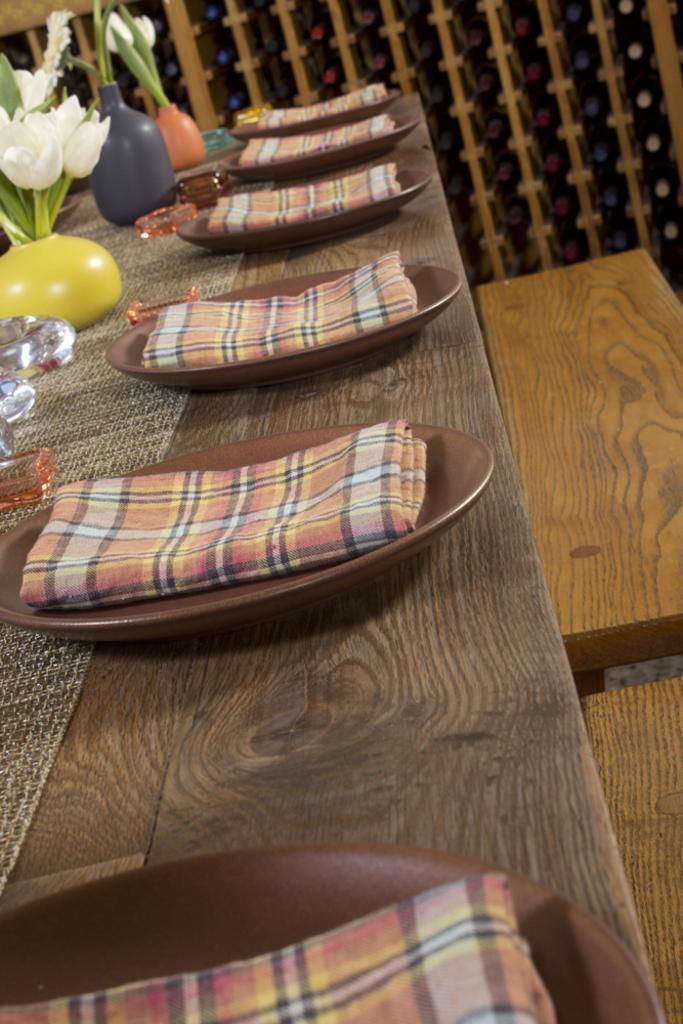Can you describe this image briefly? In this image there is a table having plates, flower vases and few objects. There are napkins on the plates. There are flowers and leaves in the vases. Right side there are benches on the floor. Background there is a wall. 